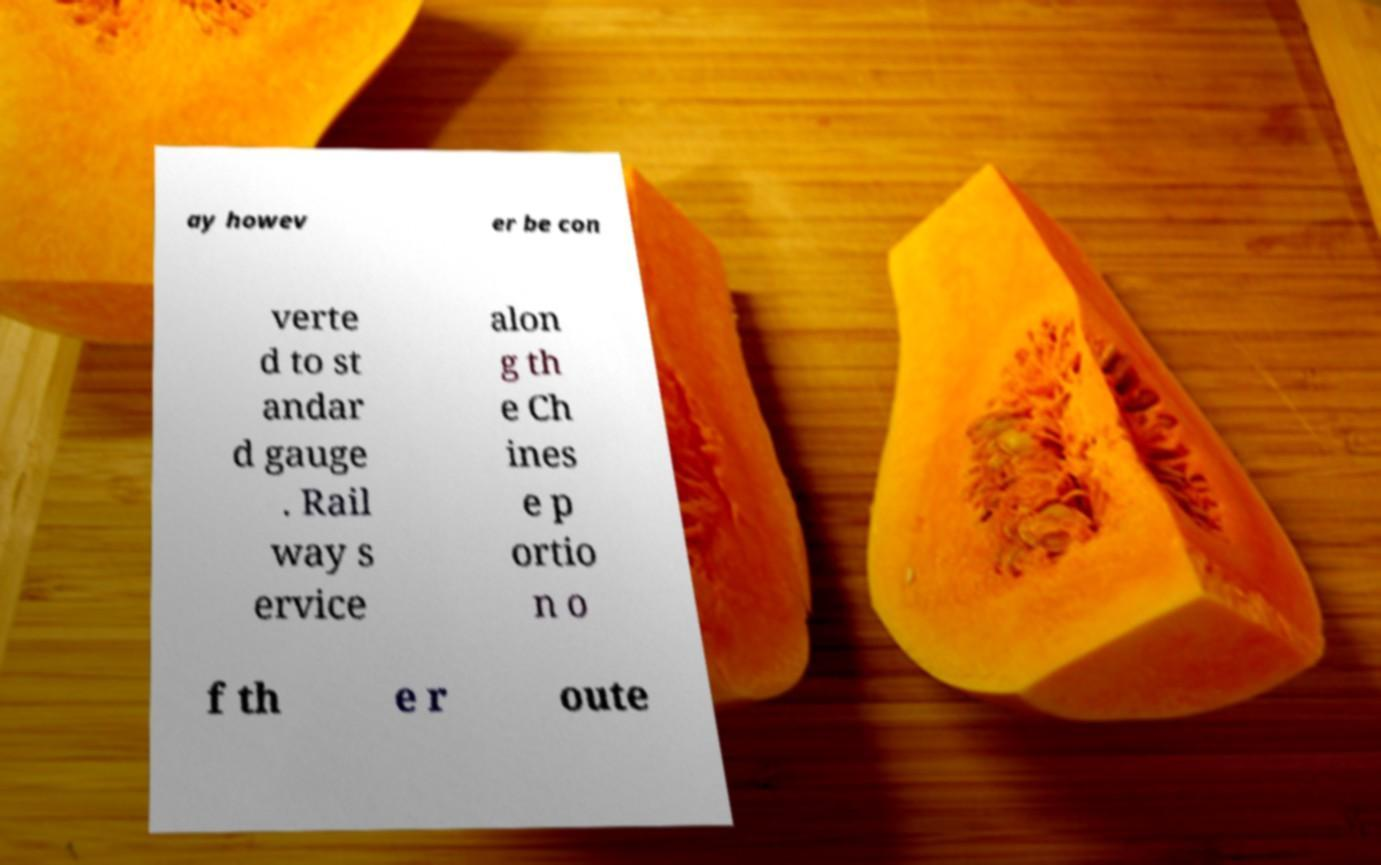I need the written content from this picture converted into text. Can you do that? ay howev er be con verte d to st andar d gauge . Rail way s ervice alon g th e Ch ines e p ortio n o f th e r oute 